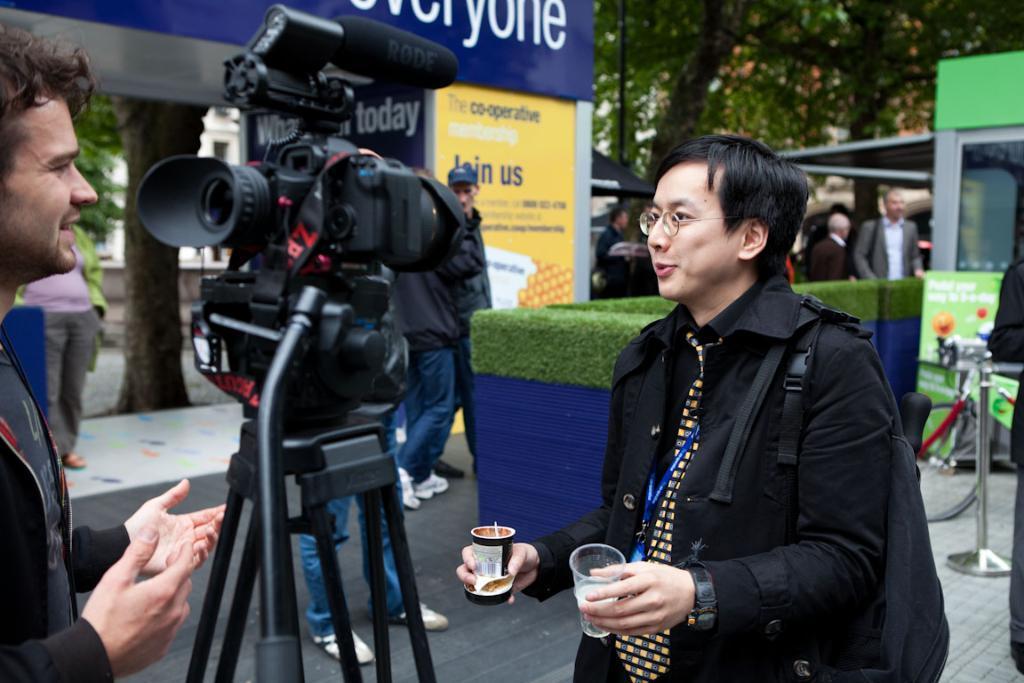How would you summarize this image in a sentence or two? In this picture there is a Chinese man wearing a black color coat and back pack on the back and holding two glasses in the hand, smiling and giving a oppose into the camera. Beside there is a cameraman with the camera. In the background we can see the yellow and blue color banner poster and some trees. 